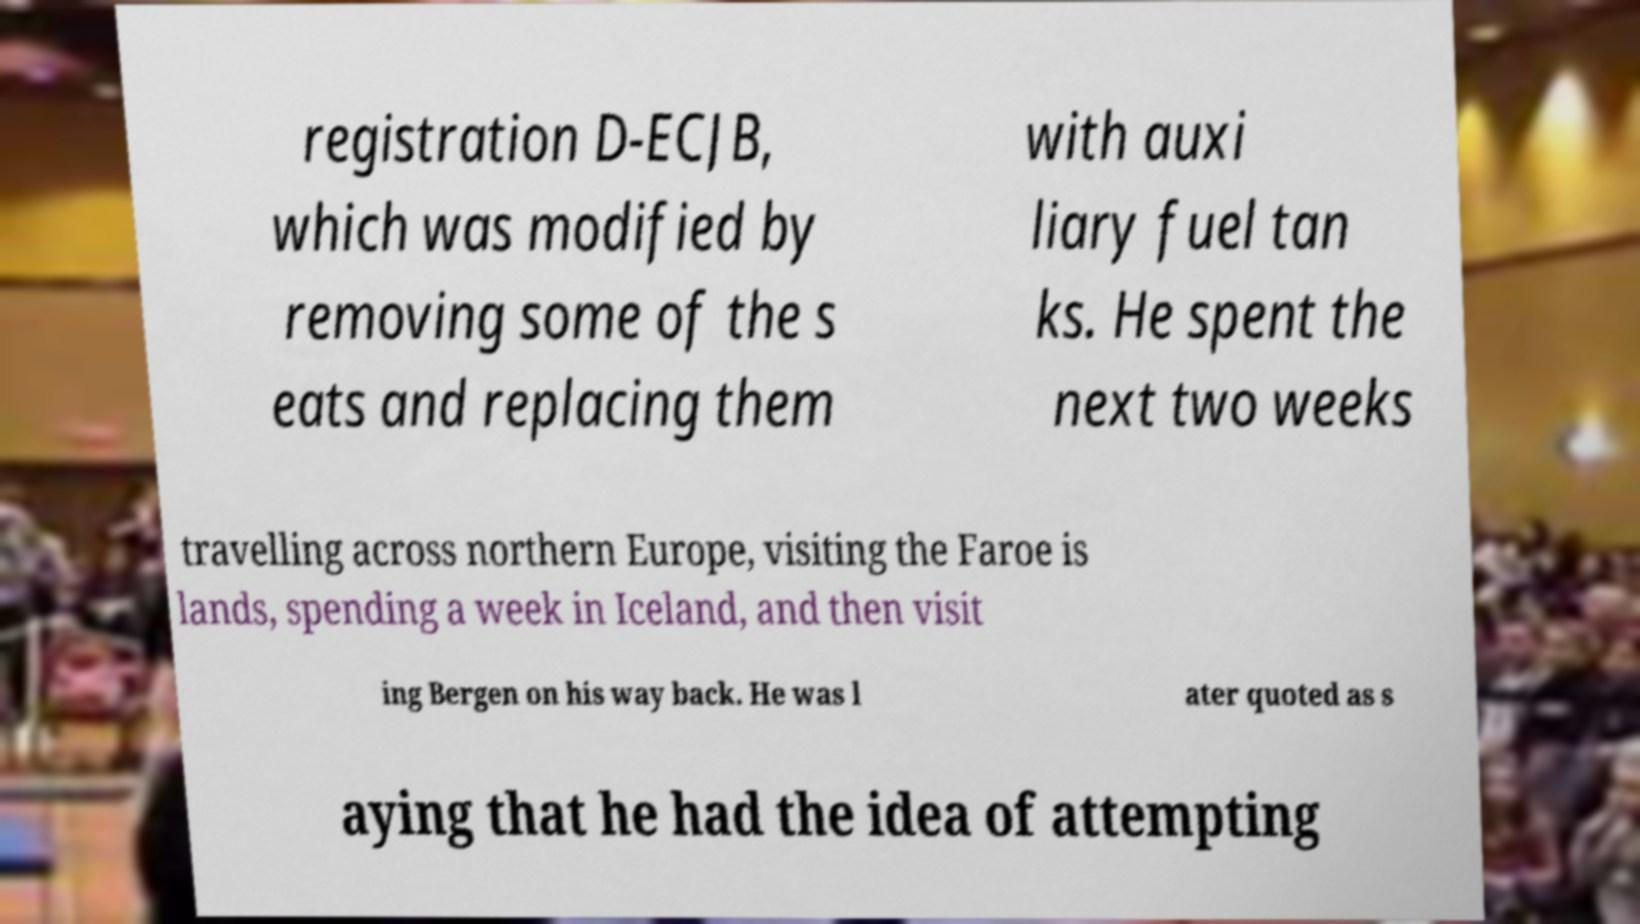Can you accurately transcribe the text from the provided image for me? registration D-ECJB, which was modified by removing some of the s eats and replacing them with auxi liary fuel tan ks. He spent the next two weeks travelling across northern Europe, visiting the Faroe is lands, spending a week in Iceland, and then visit ing Bergen on his way back. He was l ater quoted as s aying that he had the idea of attempting 